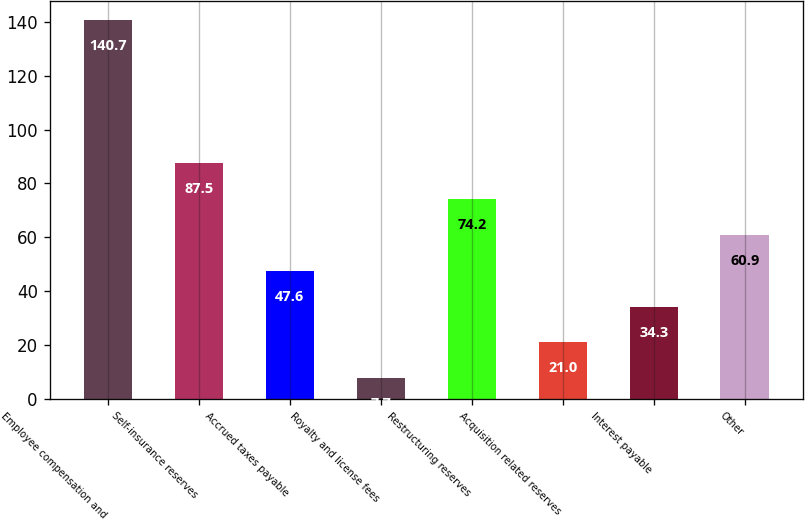Convert chart to OTSL. <chart><loc_0><loc_0><loc_500><loc_500><bar_chart><fcel>Employee compensation and<fcel>Self-insurance reserves<fcel>Accrued taxes payable<fcel>Royalty and license fees<fcel>Restructuring reserves<fcel>Acquisition related reserves<fcel>Interest payable<fcel>Other<nl><fcel>140.7<fcel>87.5<fcel>47.6<fcel>7.7<fcel>74.2<fcel>21<fcel>34.3<fcel>60.9<nl></chart> 